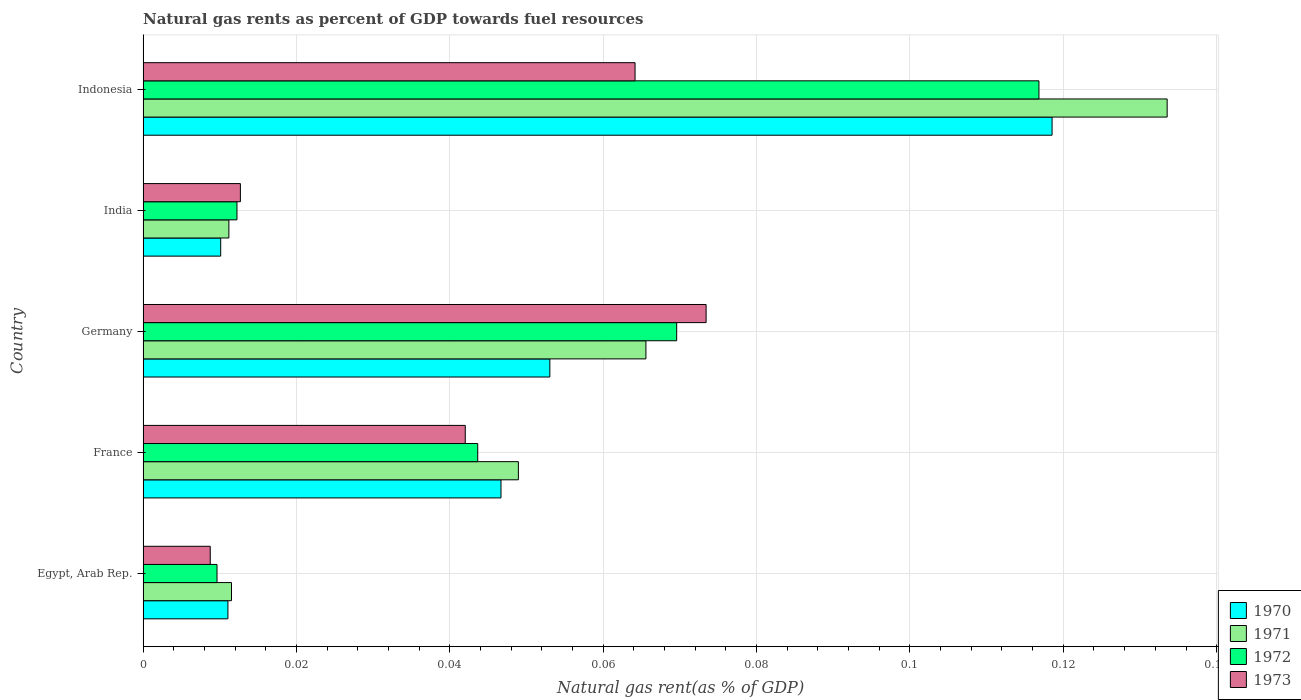How many groups of bars are there?
Your answer should be very brief. 5. Are the number of bars on each tick of the Y-axis equal?
Offer a very short reply. Yes. How many bars are there on the 4th tick from the bottom?
Offer a very short reply. 4. In how many cases, is the number of bars for a given country not equal to the number of legend labels?
Give a very brief answer. 0. What is the natural gas rent in 1972 in India?
Your answer should be very brief. 0.01. Across all countries, what is the maximum natural gas rent in 1973?
Provide a short and direct response. 0.07. Across all countries, what is the minimum natural gas rent in 1970?
Offer a very short reply. 0.01. What is the total natural gas rent in 1970 in the graph?
Offer a terse response. 0.24. What is the difference between the natural gas rent in 1973 in France and that in India?
Make the answer very short. 0.03. What is the difference between the natural gas rent in 1973 in France and the natural gas rent in 1971 in Germany?
Make the answer very short. -0.02. What is the average natural gas rent in 1972 per country?
Your answer should be very brief. 0.05. What is the difference between the natural gas rent in 1971 and natural gas rent in 1972 in France?
Ensure brevity in your answer.  0.01. What is the ratio of the natural gas rent in 1972 in France to that in Germany?
Offer a terse response. 0.63. Is the natural gas rent in 1971 in Germany less than that in Indonesia?
Offer a terse response. Yes. Is the difference between the natural gas rent in 1971 in Germany and Indonesia greater than the difference between the natural gas rent in 1972 in Germany and Indonesia?
Your response must be concise. No. What is the difference between the highest and the second highest natural gas rent in 1972?
Give a very brief answer. 0.05. What is the difference between the highest and the lowest natural gas rent in 1971?
Ensure brevity in your answer.  0.12. What does the 4th bar from the top in France represents?
Your answer should be very brief. 1970. Is it the case that in every country, the sum of the natural gas rent in 1971 and natural gas rent in 1973 is greater than the natural gas rent in 1970?
Give a very brief answer. Yes. Are all the bars in the graph horizontal?
Give a very brief answer. Yes. Does the graph contain grids?
Give a very brief answer. Yes. How are the legend labels stacked?
Your answer should be very brief. Vertical. What is the title of the graph?
Your answer should be compact. Natural gas rents as percent of GDP towards fuel resources. What is the label or title of the X-axis?
Keep it short and to the point. Natural gas rent(as % of GDP). What is the label or title of the Y-axis?
Offer a terse response. Country. What is the Natural gas rent(as % of GDP) in 1970 in Egypt, Arab Rep.?
Your answer should be compact. 0.01. What is the Natural gas rent(as % of GDP) of 1971 in Egypt, Arab Rep.?
Your response must be concise. 0.01. What is the Natural gas rent(as % of GDP) of 1972 in Egypt, Arab Rep.?
Keep it short and to the point. 0.01. What is the Natural gas rent(as % of GDP) of 1973 in Egypt, Arab Rep.?
Your answer should be compact. 0.01. What is the Natural gas rent(as % of GDP) of 1970 in France?
Offer a very short reply. 0.05. What is the Natural gas rent(as % of GDP) in 1971 in France?
Offer a terse response. 0.05. What is the Natural gas rent(as % of GDP) of 1972 in France?
Keep it short and to the point. 0.04. What is the Natural gas rent(as % of GDP) of 1973 in France?
Give a very brief answer. 0.04. What is the Natural gas rent(as % of GDP) of 1970 in Germany?
Provide a short and direct response. 0.05. What is the Natural gas rent(as % of GDP) in 1971 in Germany?
Keep it short and to the point. 0.07. What is the Natural gas rent(as % of GDP) in 1972 in Germany?
Your response must be concise. 0.07. What is the Natural gas rent(as % of GDP) of 1973 in Germany?
Provide a succinct answer. 0.07. What is the Natural gas rent(as % of GDP) in 1970 in India?
Your answer should be compact. 0.01. What is the Natural gas rent(as % of GDP) of 1971 in India?
Your answer should be compact. 0.01. What is the Natural gas rent(as % of GDP) of 1972 in India?
Give a very brief answer. 0.01. What is the Natural gas rent(as % of GDP) of 1973 in India?
Your answer should be very brief. 0.01. What is the Natural gas rent(as % of GDP) of 1970 in Indonesia?
Give a very brief answer. 0.12. What is the Natural gas rent(as % of GDP) in 1971 in Indonesia?
Keep it short and to the point. 0.13. What is the Natural gas rent(as % of GDP) in 1972 in Indonesia?
Your response must be concise. 0.12. What is the Natural gas rent(as % of GDP) in 1973 in Indonesia?
Give a very brief answer. 0.06. Across all countries, what is the maximum Natural gas rent(as % of GDP) in 1970?
Your answer should be very brief. 0.12. Across all countries, what is the maximum Natural gas rent(as % of GDP) in 1971?
Keep it short and to the point. 0.13. Across all countries, what is the maximum Natural gas rent(as % of GDP) of 1972?
Ensure brevity in your answer.  0.12. Across all countries, what is the maximum Natural gas rent(as % of GDP) of 1973?
Ensure brevity in your answer.  0.07. Across all countries, what is the minimum Natural gas rent(as % of GDP) of 1970?
Offer a terse response. 0.01. Across all countries, what is the minimum Natural gas rent(as % of GDP) in 1971?
Offer a terse response. 0.01. Across all countries, what is the minimum Natural gas rent(as % of GDP) in 1972?
Your answer should be compact. 0.01. Across all countries, what is the minimum Natural gas rent(as % of GDP) of 1973?
Provide a short and direct response. 0.01. What is the total Natural gas rent(as % of GDP) of 1970 in the graph?
Give a very brief answer. 0.24. What is the total Natural gas rent(as % of GDP) of 1971 in the graph?
Give a very brief answer. 0.27. What is the total Natural gas rent(as % of GDP) in 1972 in the graph?
Provide a short and direct response. 0.25. What is the total Natural gas rent(as % of GDP) of 1973 in the graph?
Offer a very short reply. 0.2. What is the difference between the Natural gas rent(as % of GDP) in 1970 in Egypt, Arab Rep. and that in France?
Make the answer very short. -0.04. What is the difference between the Natural gas rent(as % of GDP) in 1971 in Egypt, Arab Rep. and that in France?
Provide a short and direct response. -0.04. What is the difference between the Natural gas rent(as % of GDP) in 1972 in Egypt, Arab Rep. and that in France?
Provide a succinct answer. -0.03. What is the difference between the Natural gas rent(as % of GDP) of 1973 in Egypt, Arab Rep. and that in France?
Provide a succinct answer. -0.03. What is the difference between the Natural gas rent(as % of GDP) in 1970 in Egypt, Arab Rep. and that in Germany?
Provide a succinct answer. -0.04. What is the difference between the Natural gas rent(as % of GDP) in 1971 in Egypt, Arab Rep. and that in Germany?
Make the answer very short. -0.05. What is the difference between the Natural gas rent(as % of GDP) of 1972 in Egypt, Arab Rep. and that in Germany?
Make the answer very short. -0.06. What is the difference between the Natural gas rent(as % of GDP) of 1973 in Egypt, Arab Rep. and that in Germany?
Your answer should be compact. -0.06. What is the difference between the Natural gas rent(as % of GDP) in 1970 in Egypt, Arab Rep. and that in India?
Ensure brevity in your answer.  0. What is the difference between the Natural gas rent(as % of GDP) of 1971 in Egypt, Arab Rep. and that in India?
Your response must be concise. 0. What is the difference between the Natural gas rent(as % of GDP) in 1972 in Egypt, Arab Rep. and that in India?
Offer a very short reply. -0. What is the difference between the Natural gas rent(as % of GDP) in 1973 in Egypt, Arab Rep. and that in India?
Keep it short and to the point. -0. What is the difference between the Natural gas rent(as % of GDP) in 1970 in Egypt, Arab Rep. and that in Indonesia?
Provide a short and direct response. -0.11. What is the difference between the Natural gas rent(as % of GDP) of 1971 in Egypt, Arab Rep. and that in Indonesia?
Your answer should be very brief. -0.12. What is the difference between the Natural gas rent(as % of GDP) in 1972 in Egypt, Arab Rep. and that in Indonesia?
Your response must be concise. -0.11. What is the difference between the Natural gas rent(as % of GDP) of 1973 in Egypt, Arab Rep. and that in Indonesia?
Your answer should be compact. -0.06. What is the difference between the Natural gas rent(as % of GDP) of 1970 in France and that in Germany?
Ensure brevity in your answer.  -0.01. What is the difference between the Natural gas rent(as % of GDP) of 1971 in France and that in Germany?
Ensure brevity in your answer.  -0.02. What is the difference between the Natural gas rent(as % of GDP) in 1972 in France and that in Germany?
Ensure brevity in your answer.  -0.03. What is the difference between the Natural gas rent(as % of GDP) of 1973 in France and that in Germany?
Make the answer very short. -0.03. What is the difference between the Natural gas rent(as % of GDP) of 1970 in France and that in India?
Give a very brief answer. 0.04. What is the difference between the Natural gas rent(as % of GDP) in 1971 in France and that in India?
Offer a very short reply. 0.04. What is the difference between the Natural gas rent(as % of GDP) of 1972 in France and that in India?
Keep it short and to the point. 0.03. What is the difference between the Natural gas rent(as % of GDP) of 1973 in France and that in India?
Give a very brief answer. 0.03. What is the difference between the Natural gas rent(as % of GDP) in 1970 in France and that in Indonesia?
Ensure brevity in your answer.  -0.07. What is the difference between the Natural gas rent(as % of GDP) in 1971 in France and that in Indonesia?
Your response must be concise. -0.08. What is the difference between the Natural gas rent(as % of GDP) in 1972 in France and that in Indonesia?
Offer a very short reply. -0.07. What is the difference between the Natural gas rent(as % of GDP) of 1973 in France and that in Indonesia?
Ensure brevity in your answer.  -0.02. What is the difference between the Natural gas rent(as % of GDP) of 1970 in Germany and that in India?
Offer a terse response. 0.04. What is the difference between the Natural gas rent(as % of GDP) in 1971 in Germany and that in India?
Make the answer very short. 0.05. What is the difference between the Natural gas rent(as % of GDP) of 1972 in Germany and that in India?
Give a very brief answer. 0.06. What is the difference between the Natural gas rent(as % of GDP) in 1973 in Germany and that in India?
Provide a short and direct response. 0.06. What is the difference between the Natural gas rent(as % of GDP) of 1970 in Germany and that in Indonesia?
Give a very brief answer. -0.07. What is the difference between the Natural gas rent(as % of GDP) of 1971 in Germany and that in Indonesia?
Offer a very short reply. -0.07. What is the difference between the Natural gas rent(as % of GDP) of 1972 in Germany and that in Indonesia?
Keep it short and to the point. -0.05. What is the difference between the Natural gas rent(as % of GDP) of 1973 in Germany and that in Indonesia?
Ensure brevity in your answer.  0.01. What is the difference between the Natural gas rent(as % of GDP) of 1970 in India and that in Indonesia?
Your answer should be very brief. -0.11. What is the difference between the Natural gas rent(as % of GDP) in 1971 in India and that in Indonesia?
Provide a short and direct response. -0.12. What is the difference between the Natural gas rent(as % of GDP) of 1972 in India and that in Indonesia?
Your answer should be very brief. -0.1. What is the difference between the Natural gas rent(as % of GDP) in 1973 in India and that in Indonesia?
Give a very brief answer. -0.05. What is the difference between the Natural gas rent(as % of GDP) of 1970 in Egypt, Arab Rep. and the Natural gas rent(as % of GDP) of 1971 in France?
Ensure brevity in your answer.  -0.04. What is the difference between the Natural gas rent(as % of GDP) of 1970 in Egypt, Arab Rep. and the Natural gas rent(as % of GDP) of 1972 in France?
Give a very brief answer. -0.03. What is the difference between the Natural gas rent(as % of GDP) of 1970 in Egypt, Arab Rep. and the Natural gas rent(as % of GDP) of 1973 in France?
Offer a terse response. -0.03. What is the difference between the Natural gas rent(as % of GDP) of 1971 in Egypt, Arab Rep. and the Natural gas rent(as % of GDP) of 1972 in France?
Provide a succinct answer. -0.03. What is the difference between the Natural gas rent(as % of GDP) in 1971 in Egypt, Arab Rep. and the Natural gas rent(as % of GDP) in 1973 in France?
Ensure brevity in your answer.  -0.03. What is the difference between the Natural gas rent(as % of GDP) of 1972 in Egypt, Arab Rep. and the Natural gas rent(as % of GDP) of 1973 in France?
Your answer should be compact. -0.03. What is the difference between the Natural gas rent(as % of GDP) in 1970 in Egypt, Arab Rep. and the Natural gas rent(as % of GDP) in 1971 in Germany?
Your answer should be compact. -0.05. What is the difference between the Natural gas rent(as % of GDP) in 1970 in Egypt, Arab Rep. and the Natural gas rent(as % of GDP) in 1972 in Germany?
Offer a terse response. -0.06. What is the difference between the Natural gas rent(as % of GDP) in 1970 in Egypt, Arab Rep. and the Natural gas rent(as % of GDP) in 1973 in Germany?
Ensure brevity in your answer.  -0.06. What is the difference between the Natural gas rent(as % of GDP) in 1971 in Egypt, Arab Rep. and the Natural gas rent(as % of GDP) in 1972 in Germany?
Offer a terse response. -0.06. What is the difference between the Natural gas rent(as % of GDP) of 1971 in Egypt, Arab Rep. and the Natural gas rent(as % of GDP) of 1973 in Germany?
Give a very brief answer. -0.06. What is the difference between the Natural gas rent(as % of GDP) in 1972 in Egypt, Arab Rep. and the Natural gas rent(as % of GDP) in 1973 in Germany?
Your response must be concise. -0.06. What is the difference between the Natural gas rent(as % of GDP) in 1970 in Egypt, Arab Rep. and the Natural gas rent(as % of GDP) in 1971 in India?
Provide a short and direct response. -0. What is the difference between the Natural gas rent(as % of GDP) of 1970 in Egypt, Arab Rep. and the Natural gas rent(as % of GDP) of 1972 in India?
Provide a succinct answer. -0. What is the difference between the Natural gas rent(as % of GDP) in 1970 in Egypt, Arab Rep. and the Natural gas rent(as % of GDP) in 1973 in India?
Make the answer very short. -0. What is the difference between the Natural gas rent(as % of GDP) in 1971 in Egypt, Arab Rep. and the Natural gas rent(as % of GDP) in 1972 in India?
Your answer should be compact. -0. What is the difference between the Natural gas rent(as % of GDP) of 1971 in Egypt, Arab Rep. and the Natural gas rent(as % of GDP) of 1973 in India?
Give a very brief answer. -0. What is the difference between the Natural gas rent(as % of GDP) of 1972 in Egypt, Arab Rep. and the Natural gas rent(as % of GDP) of 1973 in India?
Your answer should be very brief. -0. What is the difference between the Natural gas rent(as % of GDP) of 1970 in Egypt, Arab Rep. and the Natural gas rent(as % of GDP) of 1971 in Indonesia?
Offer a terse response. -0.12. What is the difference between the Natural gas rent(as % of GDP) of 1970 in Egypt, Arab Rep. and the Natural gas rent(as % of GDP) of 1972 in Indonesia?
Provide a succinct answer. -0.11. What is the difference between the Natural gas rent(as % of GDP) of 1970 in Egypt, Arab Rep. and the Natural gas rent(as % of GDP) of 1973 in Indonesia?
Offer a very short reply. -0.05. What is the difference between the Natural gas rent(as % of GDP) in 1971 in Egypt, Arab Rep. and the Natural gas rent(as % of GDP) in 1972 in Indonesia?
Keep it short and to the point. -0.11. What is the difference between the Natural gas rent(as % of GDP) of 1971 in Egypt, Arab Rep. and the Natural gas rent(as % of GDP) of 1973 in Indonesia?
Your answer should be compact. -0.05. What is the difference between the Natural gas rent(as % of GDP) in 1972 in Egypt, Arab Rep. and the Natural gas rent(as % of GDP) in 1973 in Indonesia?
Make the answer very short. -0.05. What is the difference between the Natural gas rent(as % of GDP) of 1970 in France and the Natural gas rent(as % of GDP) of 1971 in Germany?
Provide a short and direct response. -0.02. What is the difference between the Natural gas rent(as % of GDP) of 1970 in France and the Natural gas rent(as % of GDP) of 1972 in Germany?
Your answer should be very brief. -0.02. What is the difference between the Natural gas rent(as % of GDP) in 1970 in France and the Natural gas rent(as % of GDP) in 1973 in Germany?
Your answer should be very brief. -0.03. What is the difference between the Natural gas rent(as % of GDP) in 1971 in France and the Natural gas rent(as % of GDP) in 1972 in Germany?
Offer a very short reply. -0.02. What is the difference between the Natural gas rent(as % of GDP) of 1971 in France and the Natural gas rent(as % of GDP) of 1973 in Germany?
Ensure brevity in your answer.  -0.02. What is the difference between the Natural gas rent(as % of GDP) in 1972 in France and the Natural gas rent(as % of GDP) in 1973 in Germany?
Offer a very short reply. -0.03. What is the difference between the Natural gas rent(as % of GDP) in 1970 in France and the Natural gas rent(as % of GDP) in 1971 in India?
Offer a terse response. 0.04. What is the difference between the Natural gas rent(as % of GDP) of 1970 in France and the Natural gas rent(as % of GDP) of 1972 in India?
Keep it short and to the point. 0.03. What is the difference between the Natural gas rent(as % of GDP) in 1970 in France and the Natural gas rent(as % of GDP) in 1973 in India?
Make the answer very short. 0.03. What is the difference between the Natural gas rent(as % of GDP) in 1971 in France and the Natural gas rent(as % of GDP) in 1972 in India?
Make the answer very short. 0.04. What is the difference between the Natural gas rent(as % of GDP) of 1971 in France and the Natural gas rent(as % of GDP) of 1973 in India?
Make the answer very short. 0.04. What is the difference between the Natural gas rent(as % of GDP) in 1972 in France and the Natural gas rent(as % of GDP) in 1973 in India?
Make the answer very short. 0.03. What is the difference between the Natural gas rent(as % of GDP) of 1970 in France and the Natural gas rent(as % of GDP) of 1971 in Indonesia?
Your answer should be compact. -0.09. What is the difference between the Natural gas rent(as % of GDP) in 1970 in France and the Natural gas rent(as % of GDP) in 1972 in Indonesia?
Keep it short and to the point. -0.07. What is the difference between the Natural gas rent(as % of GDP) in 1970 in France and the Natural gas rent(as % of GDP) in 1973 in Indonesia?
Your answer should be compact. -0.02. What is the difference between the Natural gas rent(as % of GDP) in 1971 in France and the Natural gas rent(as % of GDP) in 1972 in Indonesia?
Your response must be concise. -0.07. What is the difference between the Natural gas rent(as % of GDP) in 1971 in France and the Natural gas rent(as % of GDP) in 1973 in Indonesia?
Make the answer very short. -0.02. What is the difference between the Natural gas rent(as % of GDP) in 1972 in France and the Natural gas rent(as % of GDP) in 1973 in Indonesia?
Keep it short and to the point. -0.02. What is the difference between the Natural gas rent(as % of GDP) of 1970 in Germany and the Natural gas rent(as % of GDP) of 1971 in India?
Your response must be concise. 0.04. What is the difference between the Natural gas rent(as % of GDP) in 1970 in Germany and the Natural gas rent(as % of GDP) in 1972 in India?
Your answer should be very brief. 0.04. What is the difference between the Natural gas rent(as % of GDP) of 1970 in Germany and the Natural gas rent(as % of GDP) of 1973 in India?
Make the answer very short. 0.04. What is the difference between the Natural gas rent(as % of GDP) in 1971 in Germany and the Natural gas rent(as % of GDP) in 1972 in India?
Ensure brevity in your answer.  0.05. What is the difference between the Natural gas rent(as % of GDP) in 1971 in Germany and the Natural gas rent(as % of GDP) in 1973 in India?
Ensure brevity in your answer.  0.05. What is the difference between the Natural gas rent(as % of GDP) in 1972 in Germany and the Natural gas rent(as % of GDP) in 1973 in India?
Your answer should be very brief. 0.06. What is the difference between the Natural gas rent(as % of GDP) of 1970 in Germany and the Natural gas rent(as % of GDP) of 1971 in Indonesia?
Make the answer very short. -0.08. What is the difference between the Natural gas rent(as % of GDP) in 1970 in Germany and the Natural gas rent(as % of GDP) in 1972 in Indonesia?
Offer a very short reply. -0.06. What is the difference between the Natural gas rent(as % of GDP) of 1970 in Germany and the Natural gas rent(as % of GDP) of 1973 in Indonesia?
Offer a terse response. -0.01. What is the difference between the Natural gas rent(as % of GDP) of 1971 in Germany and the Natural gas rent(as % of GDP) of 1972 in Indonesia?
Your answer should be compact. -0.05. What is the difference between the Natural gas rent(as % of GDP) of 1971 in Germany and the Natural gas rent(as % of GDP) of 1973 in Indonesia?
Your answer should be compact. 0. What is the difference between the Natural gas rent(as % of GDP) in 1972 in Germany and the Natural gas rent(as % of GDP) in 1973 in Indonesia?
Your answer should be compact. 0.01. What is the difference between the Natural gas rent(as % of GDP) of 1970 in India and the Natural gas rent(as % of GDP) of 1971 in Indonesia?
Your answer should be compact. -0.12. What is the difference between the Natural gas rent(as % of GDP) of 1970 in India and the Natural gas rent(as % of GDP) of 1972 in Indonesia?
Keep it short and to the point. -0.11. What is the difference between the Natural gas rent(as % of GDP) of 1970 in India and the Natural gas rent(as % of GDP) of 1973 in Indonesia?
Make the answer very short. -0.05. What is the difference between the Natural gas rent(as % of GDP) of 1971 in India and the Natural gas rent(as % of GDP) of 1972 in Indonesia?
Your answer should be very brief. -0.11. What is the difference between the Natural gas rent(as % of GDP) of 1971 in India and the Natural gas rent(as % of GDP) of 1973 in Indonesia?
Offer a terse response. -0.05. What is the difference between the Natural gas rent(as % of GDP) in 1972 in India and the Natural gas rent(as % of GDP) in 1973 in Indonesia?
Offer a terse response. -0.05. What is the average Natural gas rent(as % of GDP) of 1970 per country?
Give a very brief answer. 0.05. What is the average Natural gas rent(as % of GDP) in 1971 per country?
Provide a succinct answer. 0.05. What is the average Natural gas rent(as % of GDP) in 1972 per country?
Your answer should be very brief. 0.05. What is the average Natural gas rent(as % of GDP) of 1973 per country?
Your answer should be very brief. 0.04. What is the difference between the Natural gas rent(as % of GDP) in 1970 and Natural gas rent(as % of GDP) in 1971 in Egypt, Arab Rep.?
Offer a very short reply. -0. What is the difference between the Natural gas rent(as % of GDP) of 1970 and Natural gas rent(as % of GDP) of 1972 in Egypt, Arab Rep.?
Offer a very short reply. 0. What is the difference between the Natural gas rent(as % of GDP) in 1970 and Natural gas rent(as % of GDP) in 1973 in Egypt, Arab Rep.?
Your answer should be compact. 0. What is the difference between the Natural gas rent(as % of GDP) of 1971 and Natural gas rent(as % of GDP) of 1972 in Egypt, Arab Rep.?
Your answer should be very brief. 0. What is the difference between the Natural gas rent(as % of GDP) of 1971 and Natural gas rent(as % of GDP) of 1973 in Egypt, Arab Rep.?
Provide a short and direct response. 0. What is the difference between the Natural gas rent(as % of GDP) of 1972 and Natural gas rent(as % of GDP) of 1973 in Egypt, Arab Rep.?
Provide a succinct answer. 0. What is the difference between the Natural gas rent(as % of GDP) in 1970 and Natural gas rent(as % of GDP) in 1971 in France?
Provide a short and direct response. -0. What is the difference between the Natural gas rent(as % of GDP) of 1970 and Natural gas rent(as % of GDP) of 1972 in France?
Ensure brevity in your answer.  0. What is the difference between the Natural gas rent(as % of GDP) in 1970 and Natural gas rent(as % of GDP) in 1973 in France?
Give a very brief answer. 0. What is the difference between the Natural gas rent(as % of GDP) in 1971 and Natural gas rent(as % of GDP) in 1972 in France?
Your response must be concise. 0.01. What is the difference between the Natural gas rent(as % of GDP) in 1971 and Natural gas rent(as % of GDP) in 1973 in France?
Your answer should be compact. 0.01. What is the difference between the Natural gas rent(as % of GDP) in 1972 and Natural gas rent(as % of GDP) in 1973 in France?
Your answer should be very brief. 0. What is the difference between the Natural gas rent(as % of GDP) in 1970 and Natural gas rent(as % of GDP) in 1971 in Germany?
Your answer should be compact. -0.01. What is the difference between the Natural gas rent(as % of GDP) in 1970 and Natural gas rent(as % of GDP) in 1972 in Germany?
Your answer should be compact. -0.02. What is the difference between the Natural gas rent(as % of GDP) of 1970 and Natural gas rent(as % of GDP) of 1973 in Germany?
Your response must be concise. -0.02. What is the difference between the Natural gas rent(as % of GDP) of 1971 and Natural gas rent(as % of GDP) of 1972 in Germany?
Your response must be concise. -0. What is the difference between the Natural gas rent(as % of GDP) of 1971 and Natural gas rent(as % of GDP) of 1973 in Germany?
Provide a short and direct response. -0.01. What is the difference between the Natural gas rent(as % of GDP) in 1972 and Natural gas rent(as % of GDP) in 1973 in Germany?
Give a very brief answer. -0. What is the difference between the Natural gas rent(as % of GDP) of 1970 and Natural gas rent(as % of GDP) of 1971 in India?
Ensure brevity in your answer.  -0. What is the difference between the Natural gas rent(as % of GDP) in 1970 and Natural gas rent(as % of GDP) in 1972 in India?
Ensure brevity in your answer.  -0. What is the difference between the Natural gas rent(as % of GDP) of 1970 and Natural gas rent(as % of GDP) of 1973 in India?
Provide a succinct answer. -0. What is the difference between the Natural gas rent(as % of GDP) in 1971 and Natural gas rent(as % of GDP) in 1972 in India?
Give a very brief answer. -0. What is the difference between the Natural gas rent(as % of GDP) of 1971 and Natural gas rent(as % of GDP) of 1973 in India?
Your response must be concise. -0. What is the difference between the Natural gas rent(as % of GDP) of 1972 and Natural gas rent(as % of GDP) of 1973 in India?
Your response must be concise. -0. What is the difference between the Natural gas rent(as % of GDP) of 1970 and Natural gas rent(as % of GDP) of 1971 in Indonesia?
Your response must be concise. -0.01. What is the difference between the Natural gas rent(as % of GDP) of 1970 and Natural gas rent(as % of GDP) of 1972 in Indonesia?
Provide a short and direct response. 0. What is the difference between the Natural gas rent(as % of GDP) in 1970 and Natural gas rent(as % of GDP) in 1973 in Indonesia?
Ensure brevity in your answer.  0.05. What is the difference between the Natural gas rent(as % of GDP) in 1971 and Natural gas rent(as % of GDP) in 1972 in Indonesia?
Provide a short and direct response. 0.02. What is the difference between the Natural gas rent(as % of GDP) in 1971 and Natural gas rent(as % of GDP) in 1973 in Indonesia?
Your answer should be very brief. 0.07. What is the difference between the Natural gas rent(as % of GDP) in 1972 and Natural gas rent(as % of GDP) in 1973 in Indonesia?
Offer a terse response. 0.05. What is the ratio of the Natural gas rent(as % of GDP) in 1970 in Egypt, Arab Rep. to that in France?
Your answer should be compact. 0.24. What is the ratio of the Natural gas rent(as % of GDP) of 1971 in Egypt, Arab Rep. to that in France?
Offer a very short reply. 0.24. What is the ratio of the Natural gas rent(as % of GDP) in 1972 in Egypt, Arab Rep. to that in France?
Give a very brief answer. 0.22. What is the ratio of the Natural gas rent(as % of GDP) of 1973 in Egypt, Arab Rep. to that in France?
Offer a terse response. 0.21. What is the ratio of the Natural gas rent(as % of GDP) of 1970 in Egypt, Arab Rep. to that in Germany?
Offer a very short reply. 0.21. What is the ratio of the Natural gas rent(as % of GDP) of 1971 in Egypt, Arab Rep. to that in Germany?
Your response must be concise. 0.18. What is the ratio of the Natural gas rent(as % of GDP) of 1972 in Egypt, Arab Rep. to that in Germany?
Offer a very short reply. 0.14. What is the ratio of the Natural gas rent(as % of GDP) of 1973 in Egypt, Arab Rep. to that in Germany?
Your answer should be very brief. 0.12. What is the ratio of the Natural gas rent(as % of GDP) of 1970 in Egypt, Arab Rep. to that in India?
Your response must be concise. 1.09. What is the ratio of the Natural gas rent(as % of GDP) of 1971 in Egypt, Arab Rep. to that in India?
Offer a terse response. 1.03. What is the ratio of the Natural gas rent(as % of GDP) in 1972 in Egypt, Arab Rep. to that in India?
Keep it short and to the point. 0.79. What is the ratio of the Natural gas rent(as % of GDP) of 1973 in Egypt, Arab Rep. to that in India?
Make the answer very short. 0.69. What is the ratio of the Natural gas rent(as % of GDP) in 1970 in Egypt, Arab Rep. to that in Indonesia?
Keep it short and to the point. 0.09. What is the ratio of the Natural gas rent(as % of GDP) in 1971 in Egypt, Arab Rep. to that in Indonesia?
Keep it short and to the point. 0.09. What is the ratio of the Natural gas rent(as % of GDP) in 1972 in Egypt, Arab Rep. to that in Indonesia?
Keep it short and to the point. 0.08. What is the ratio of the Natural gas rent(as % of GDP) of 1973 in Egypt, Arab Rep. to that in Indonesia?
Your answer should be very brief. 0.14. What is the ratio of the Natural gas rent(as % of GDP) in 1970 in France to that in Germany?
Give a very brief answer. 0.88. What is the ratio of the Natural gas rent(as % of GDP) of 1971 in France to that in Germany?
Offer a terse response. 0.75. What is the ratio of the Natural gas rent(as % of GDP) of 1972 in France to that in Germany?
Your response must be concise. 0.63. What is the ratio of the Natural gas rent(as % of GDP) in 1973 in France to that in Germany?
Your answer should be very brief. 0.57. What is the ratio of the Natural gas rent(as % of GDP) of 1970 in France to that in India?
Keep it short and to the point. 4.61. What is the ratio of the Natural gas rent(as % of GDP) in 1971 in France to that in India?
Provide a succinct answer. 4.37. What is the ratio of the Natural gas rent(as % of GDP) of 1972 in France to that in India?
Offer a terse response. 3.56. What is the ratio of the Natural gas rent(as % of GDP) in 1973 in France to that in India?
Your response must be concise. 3.31. What is the ratio of the Natural gas rent(as % of GDP) in 1970 in France to that in Indonesia?
Keep it short and to the point. 0.39. What is the ratio of the Natural gas rent(as % of GDP) in 1971 in France to that in Indonesia?
Offer a terse response. 0.37. What is the ratio of the Natural gas rent(as % of GDP) of 1972 in France to that in Indonesia?
Provide a succinct answer. 0.37. What is the ratio of the Natural gas rent(as % of GDP) of 1973 in France to that in Indonesia?
Keep it short and to the point. 0.65. What is the ratio of the Natural gas rent(as % of GDP) of 1970 in Germany to that in India?
Keep it short and to the point. 5.24. What is the ratio of the Natural gas rent(as % of GDP) in 1971 in Germany to that in India?
Offer a very short reply. 5.86. What is the ratio of the Natural gas rent(as % of GDP) in 1972 in Germany to that in India?
Ensure brevity in your answer.  5.68. What is the ratio of the Natural gas rent(as % of GDP) in 1973 in Germany to that in India?
Make the answer very short. 5.79. What is the ratio of the Natural gas rent(as % of GDP) in 1970 in Germany to that in Indonesia?
Provide a succinct answer. 0.45. What is the ratio of the Natural gas rent(as % of GDP) in 1971 in Germany to that in Indonesia?
Offer a very short reply. 0.49. What is the ratio of the Natural gas rent(as % of GDP) in 1972 in Germany to that in Indonesia?
Provide a short and direct response. 0.6. What is the ratio of the Natural gas rent(as % of GDP) in 1973 in Germany to that in Indonesia?
Provide a succinct answer. 1.14. What is the ratio of the Natural gas rent(as % of GDP) in 1970 in India to that in Indonesia?
Your answer should be compact. 0.09. What is the ratio of the Natural gas rent(as % of GDP) of 1971 in India to that in Indonesia?
Give a very brief answer. 0.08. What is the ratio of the Natural gas rent(as % of GDP) in 1972 in India to that in Indonesia?
Make the answer very short. 0.1. What is the ratio of the Natural gas rent(as % of GDP) of 1973 in India to that in Indonesia?
Your answer should be compact. 0.2. What is the difference between the highest and the second highest Natural gas rent(as % of GDP) in 1970?
Give a very brief answer. 0.07. What is the difference between the highest and the second highest Natural gas rent(as % of GDP) of 1971?
Offer a very short reply. 0.07. What is the difference between the highest and the second highest Natural gas rent(as % of GDP) in 1972?
Ensure brevity in your answer.  0.05. What is the difference between the highest and the second highest Natural gas rent(as % of GDP) in 1973?
Give a very brief answer. 0.01. What is the difference between the highest and the lowest Natural gas rent(as % of GDP) in 1970?
Keep it short and to the point. 0.11. What is the difference between the highest and the lowest Natural gas rent(as % of GDP) in 1971?
Give a very brief answer. 0.12. What is the difference between the highest and the lowest Natural gas rent(as % of GDP) of 1972?
Give a very brief answer. 0.11. What is the difference between the highest and the lowest Natural gas rent(as % of GDP) in 1973?
Provide a succinct answer. 0.06. 